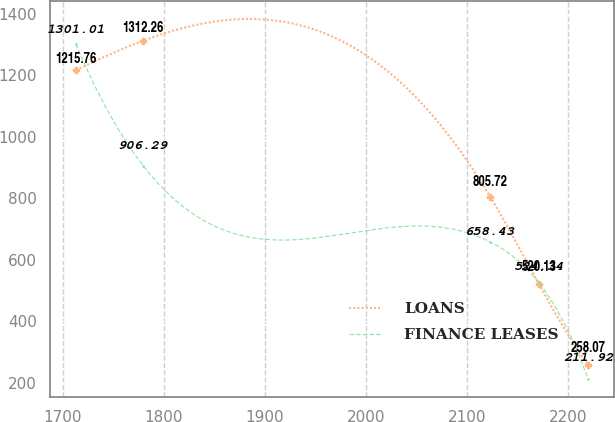<chart> <loc_0><loc_0><loc_500><loc_500><line_chart><ecel><fcel>LOANS<fcel>FINANCE LEASES<nl><fcel>1712.97<fcel>1215.76<fcel>1301.01<nl><fcel>1779.54<fcel>1312.26<fcel>906.29<nl><fcel>2123.04<fcel>805.72<fcel>658.43<nl><fcel>2171.61<fcel>520.13<fcel>524.34<nl><fcel>2220.18<fcel>258.07<fcel>211.92<nl></chart> 